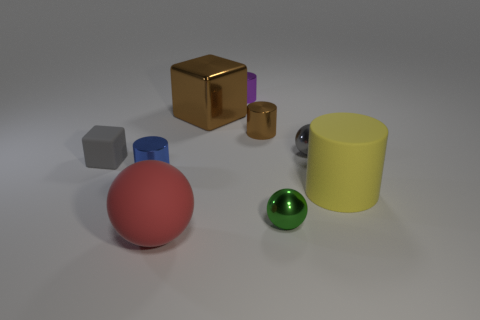Subtract all balls. How many objects are left? 6 Subtract 1 brown cubes. How many objects are left? 8 Subtract all big yellow objects. Subtract all purple shiny cylinders. How many objects are left? 7 Add 5 gray shiny things. How many gray shiny things are left? 6 Add 4 small balls. How many small balls exist? 6 